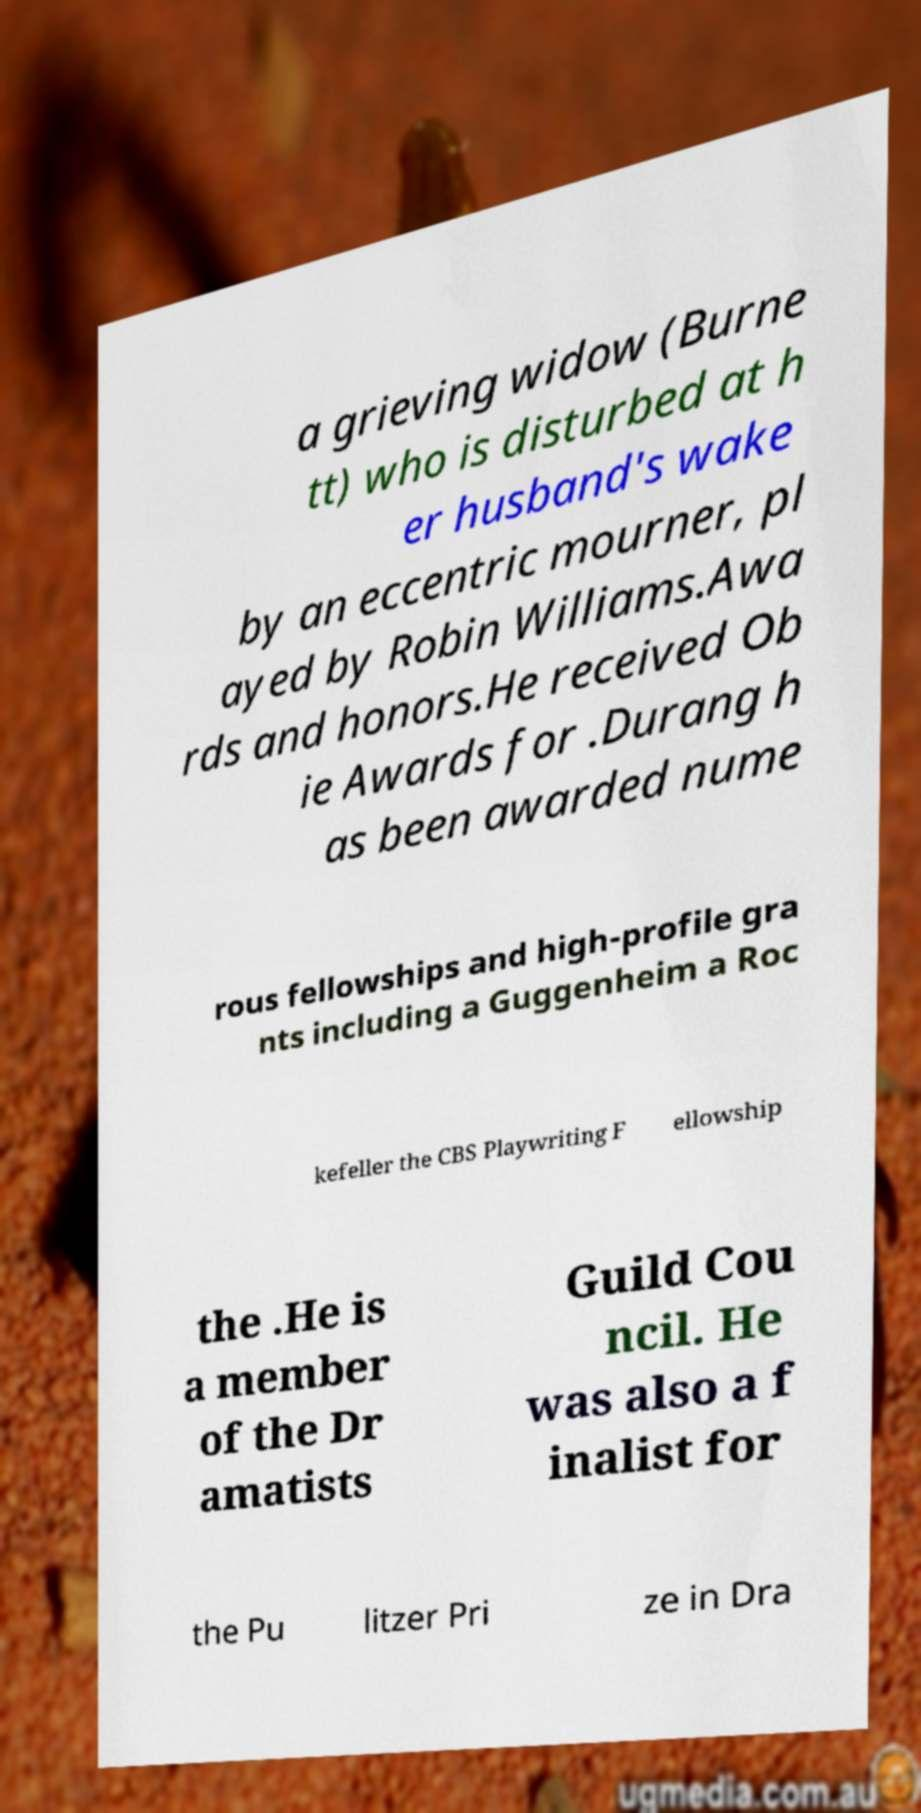There's text embedded in this image that I need extracted. Can you transcribe it verbatim? a grieving widow (Burne tt) who is disturbed at h er husband's wake by an eccentric mourner, pl ayed by Robin Williams.Awa rds and honors.He received Ob ie Awards for .Durang h as been awarded nume rous fellowships and high-profile gra nts including a Guggenheim a Roc kefeller the CBS Playwriting F ellowship the .He is a member of the Dr amatists Guild Cou ncil. He was also a f inalist for the Pu litzer Pri ze in Dra 